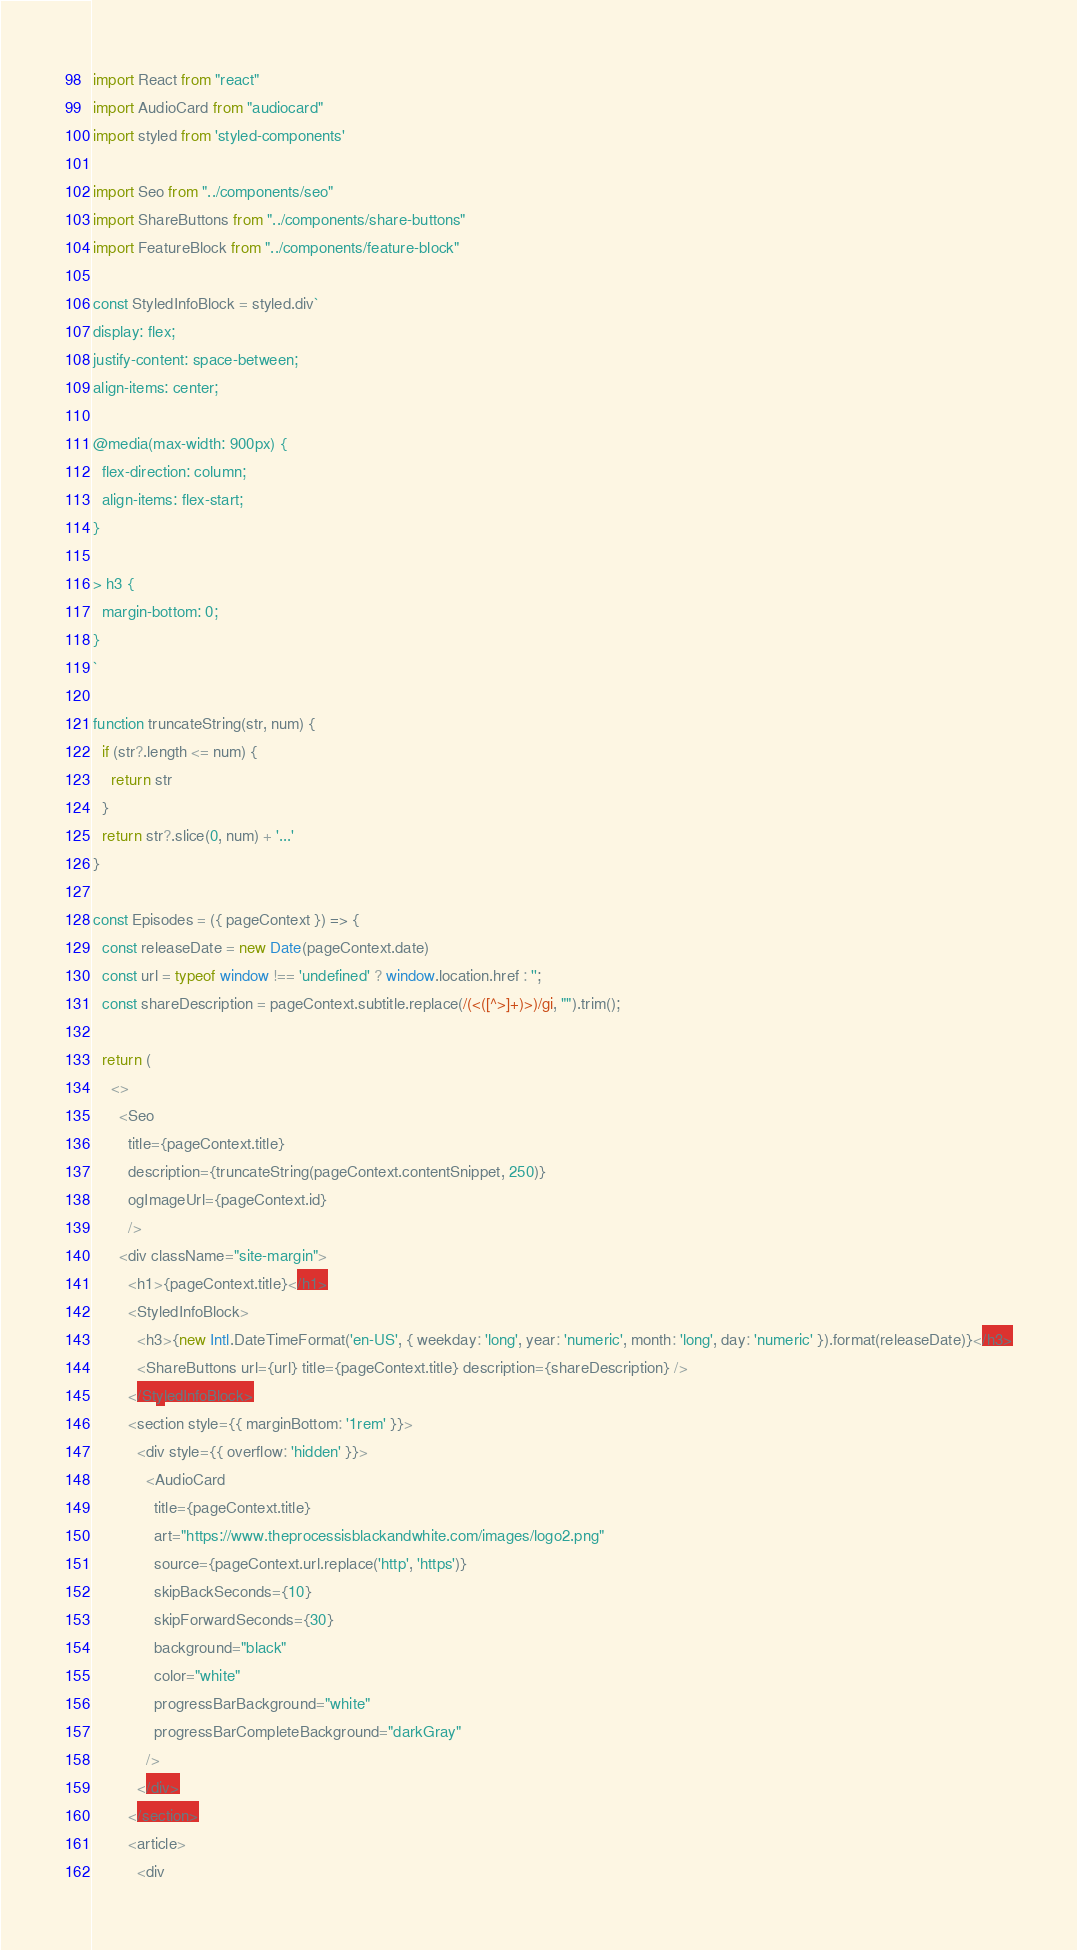<code> <loc_0><loc_0><loc_500><loc_500><_JavaScript_>import React from "react"
import AudioCard from "audiocard"
import styled from 'styled-components'

import Seo from "../components/seo"
import ShareButtons from "../components/share-buttons"
import FeatureBlock from "../components/feature-block"

const StyledInfoBlock = styled.div`
display: flex;
justify-content: space-between;
align-items: center;

@media(max-width: 900px) {
  flex-direction: column;
  align-items: flex-start;
}

> h3 {
  margin-bottom: 0;
}
`

function truncateString(str, num) {
  if (str?.length <= num) {
    return str
  }
  return str?.slice(0, num) + '...'
}

const Episodes = ({ pageContext }) => {
  const releaseDate = new Date(pageContext.date)
  const url = typeof window !== 'undefined' ? window.location.href : '';
  const shareDescription = pageContext.subtitle.replace(/(<([^>]+)>)/gi, "").trim();

  return (
    <>
      <Seo 
        title={pageContext.title} 
        description={truncateString(pageContext.contentSnippet, 250)} 
        ogImageUrl={pageContext.id}
        />
      <div className="site-margin">
        <h1>{pageContext.title}</h1>
        <StyledInfoBlock>
          <h3>{new Intl.DateTimeFormat('en-US', { weekday: 'long', year: 'numeric', month: 'long', day: 'numeric' }).format(releaseDate)}</h3>
          <ShareButtons url={url} title={pageContext.title} description={shareDescription} />
        </StyledInfoBlock>
        <section style={{ marginBottom: '1rem' }}>
          <div style={{ overflow: 'hidden' }}>
            <AudioCard
              title={pageContext.title}
              art="https://www.theprocessisblackandwhite.com/images/logo2.png"
              source={pageContext.url.replace('http', 'https')}
              skipBackSeconds={10}
              skipForwardSeconds={30}
              background="black"
              color="white"
              progressBarBackground="white"
              progressBarCompleteBackground="darkGray"
            />
          </div>
        </section>
        <article>
          <div</code> 